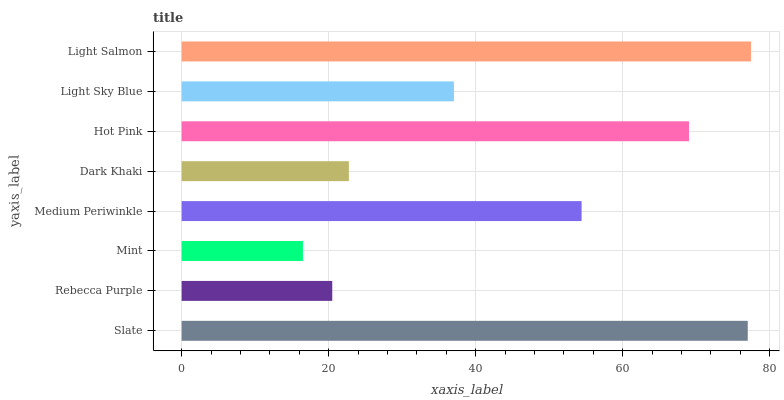Is Mint the minimum?
Answer yes or no. Yes. Is Light Salmon the maximum?
Answer yes or no. Yes. Is Rebecca Purple the minimum?
Answer yes or no. No. Is Rebecca Purple the maximum?
Answer yes or no. No. Is Slate greater than Rebecca Purple?
Answer yes or no. Yes. Is Rebecca Purple less than Slate?
Answer yes or no. Yes. Is Rebecca Purple greater than Slate?
Answer yes or no. No. Is Slate less than Rebecca Purple?
Answer yes or no. No. Is Medium Periwinkle the high median?
Answer yes or no. Yes. Is Light Sky Blue the low median?
Answer yes or no. Yes. Is Mint the high median?
Answer yes or no. No. Is Slate the low median?
Answer yes or no. No. 